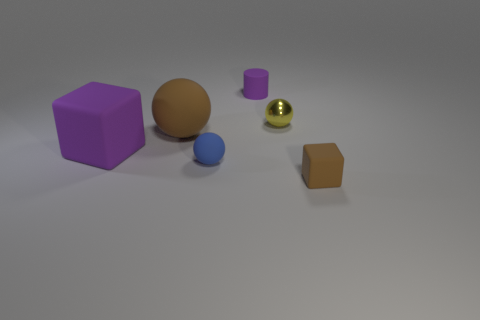Subtract all yellow balls. How many balls are left? 2 Subtract all yellow balls. How many balls are left? 2 Add 2 purple metal cylinders. How many objects exist? 8 Subtract 3 balls. How many balls are left? 0 Subtract all cylinders. How many objects are left? 5 Subtract all tiny purple metallic cylinders. Subtract all purple matte objects. How many objects are left? 4 Add 4 matte blocks. How many matte blocks are left? 6 Add 1 small cylinders. How many small cylinders exist? 2 Subtract 0 green cubes. How many objects are left? 6 Subtract all red cylinders. Subtract all green blocks. How many cylinders are left? 1 